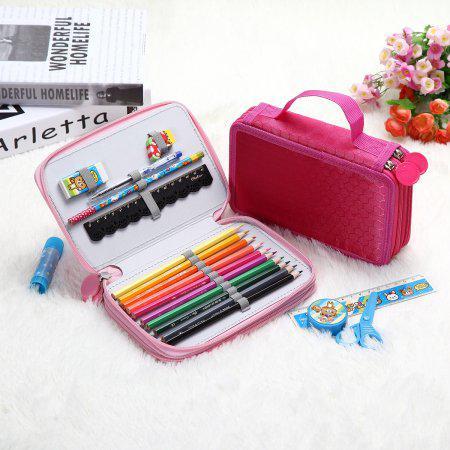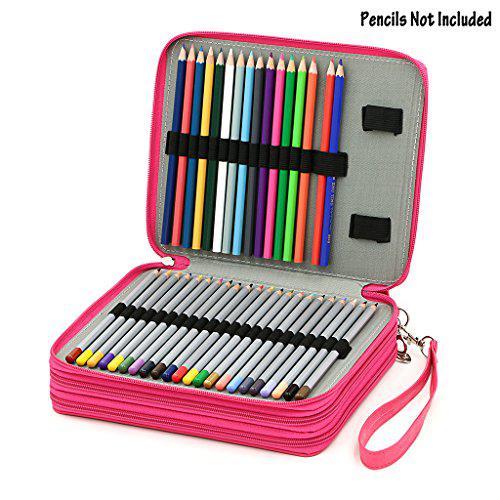The first image is the image on the left, the second image is the image on the right. For the images displayed, is the sentence "Exactly one bag is closed." factually correct? Answer yes or no. Yes. The first image is the image on the left, the second image is the image on the right. Assess this claim about the two images: "Only pencil cases with zipper closures are shown, at least one case is hot pink, one case is closed, and at least one case is open.". Correct or not? Answer yes or no. Yes. 